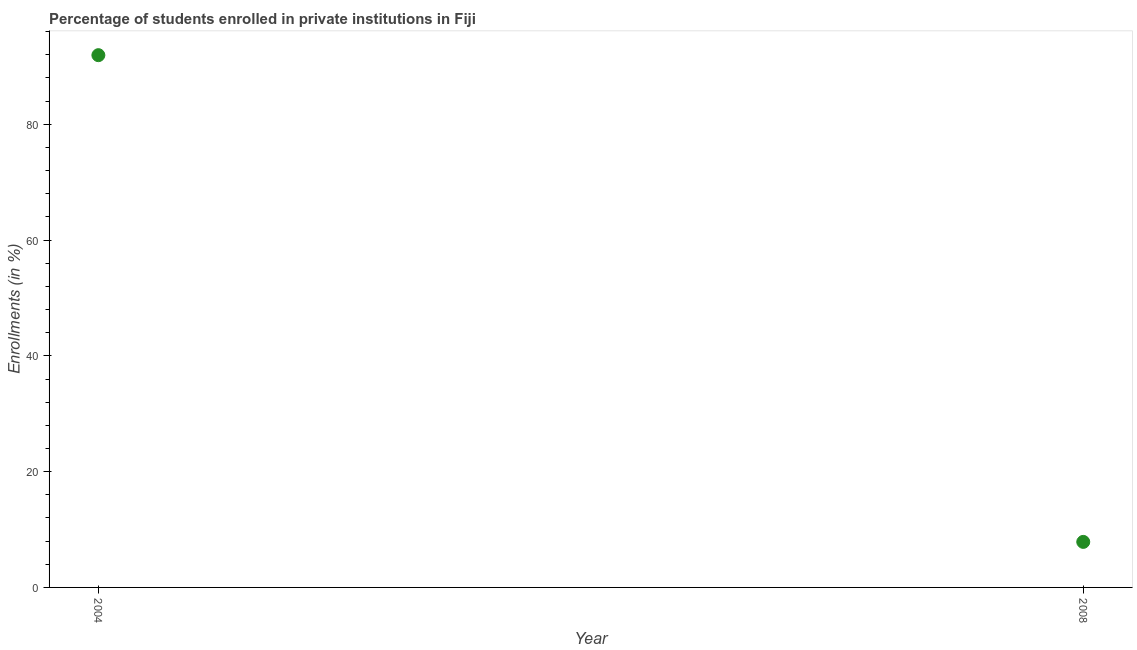What is the enrollments in private institutions in 2004?
Provide a succinct answer. 91.94. Across all years, what is the maximum enrollments in private institutions?
Your answer should be compact. 91.94. Across all years, what is the minimum enrollments in private institutions?
Your answer should be very brief. 7.87. In which year was the enrollments in private institutions minimum?
Provide a short and direct response. 2008. What is the sum of the enrollments in private institutions?
Provide a succinct answer. 99.81. What is the difference between the enrollments in private institutions in 2004 and 2008?
Your response must be concise. 84.08. What is the average enrollments in private institutions per year?
Ensure brevity in your answer.  49.91. What is the median enrollments in private institutions?
Make the answer very short. 49.91. In how many years, is the enrollments in private institutions greater than 8 %?
Give a very brief answer. 1. What is the ratio of the enrollments in private institutions in 2004 to that in 2008?
Your answer should be very brief. 11.69. Does the enrollments in private institutions monotonically increase over the years?
Your response must be concise. No. How many dotlines are there?
Give a very brief answer. 1. How many years are there in the graph?
Your answer should be very brief. 2. What is the difference between two consecutive major ticks on the Y-axis?
Offer a terse response. 20. Does the graph contain grids?
Keep it short and to the point. No. What is the title of the graph?
Your answer should be very brief. Percentage of students enrolled in private institutions in Fiji. What is the label or title of the Y-axis?
Provide a succinct answer. Enrollments (in %). What is the Enrollments (in %) in 2004?
Offer a very short reply. 91.94. What is the Enrollments (in %) in 2008?
Offer a very short reply. 7.87. What is the difference between the Enrollments (in %) in 2004 and 2008?
Provide a short and direct response. 84.08. What is the ratio of the Enrollments (in %) in 2004 to that in 2008?
Your answer should be very brief. 11.69. 